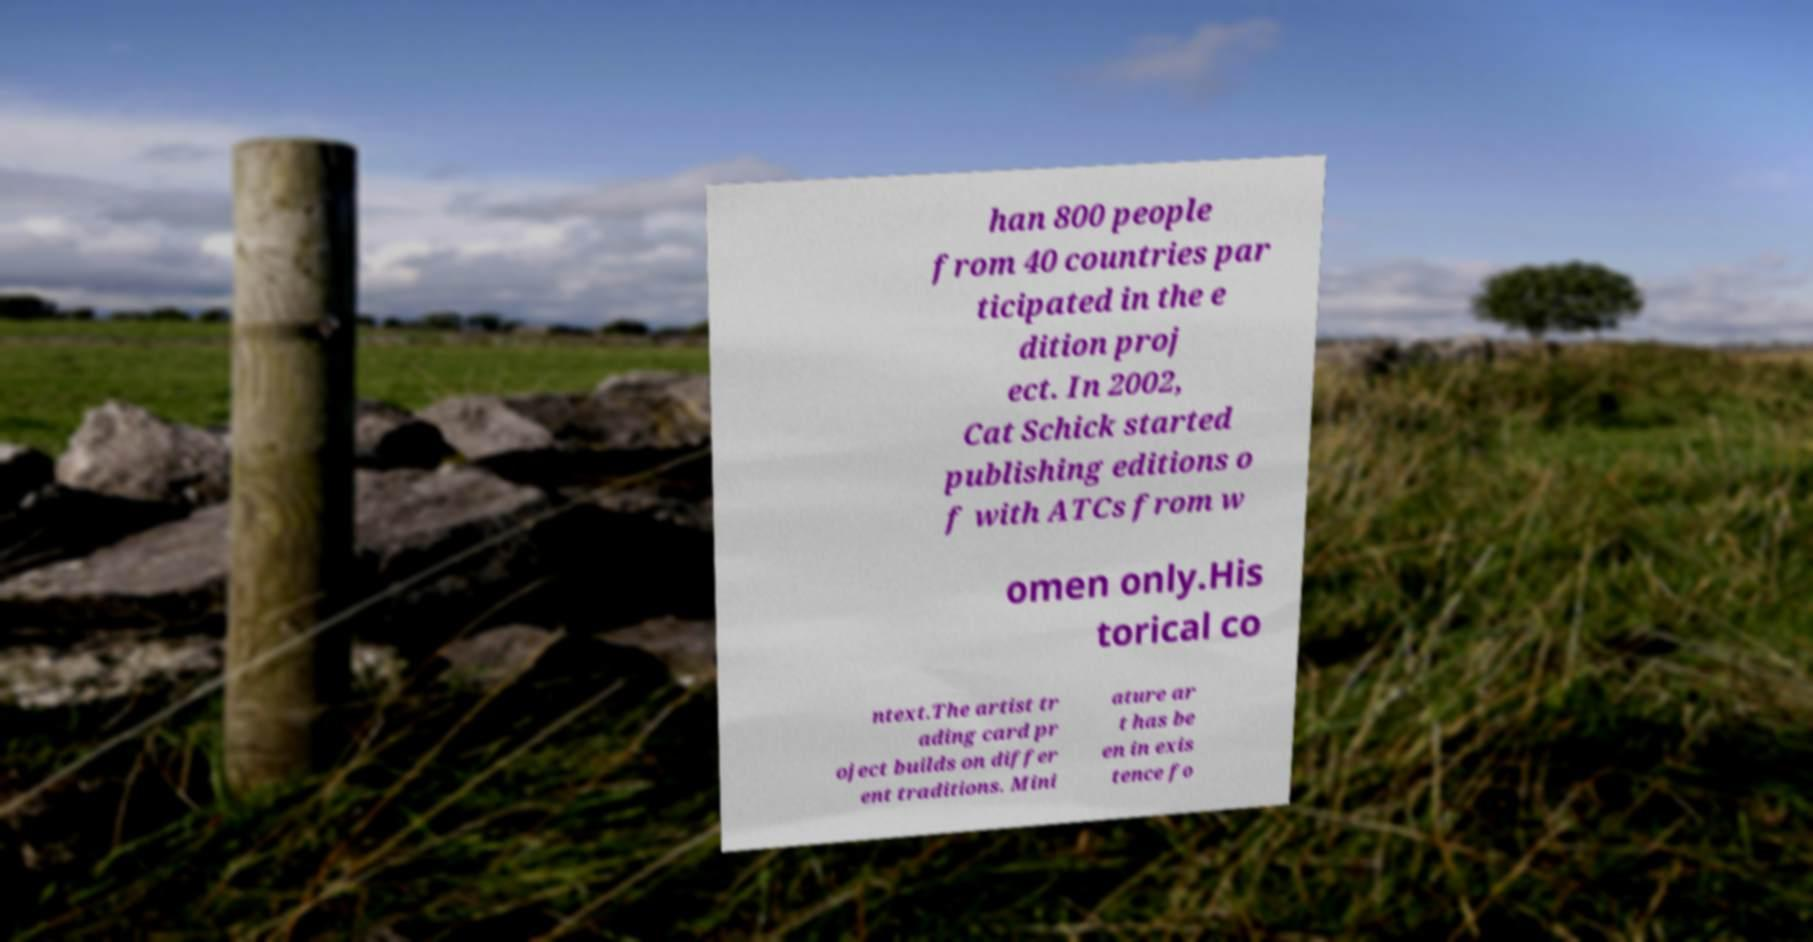Please read and relay the text visible in this image. What does it say? han 800 people from 40 countries par ticipated in the e dition proj ect. In 2002, Cat Schick started publishing editions o f with ATCs from w omen only.His torical co ntext.The artist tr ading card pr oject builds on differ ent traditions. Mini ature ar t has be en in exis tence fo 